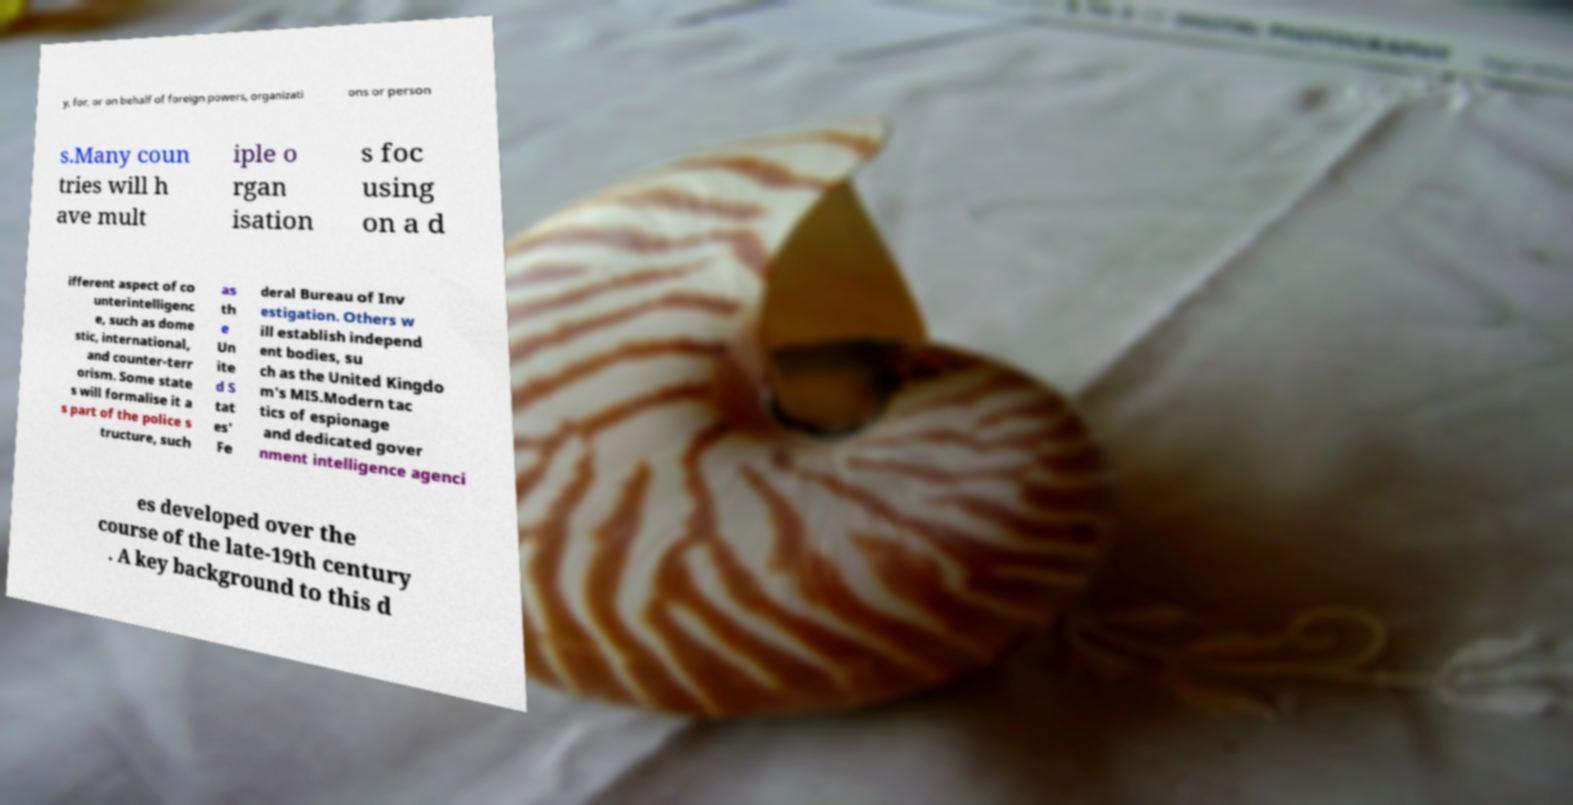Can you read and provide the text displayed in the image?This photo seems to have some interesting text. Can you extract and type it out for me? y, for, or on behalf of foreign powers, organizati ons or person s.Many coun tries will h ave mult iple o rgan isation s foc using on a d ifferent aspect of co unterintelligenc e, such as dome stic, international, and counter-terr orism. Some state s will formalise it a s part of the police s tructure, such as th e Un ite d S tat es' Fe deral Bureau of Inv estigation. Others w ill establish independ ent bodies, su ch as the United Kingdo m's MI5.Modern tac tics of espionage and dedicated gover nment intelligence agenci es developed over the course of the late-19th century . A key background to this d 